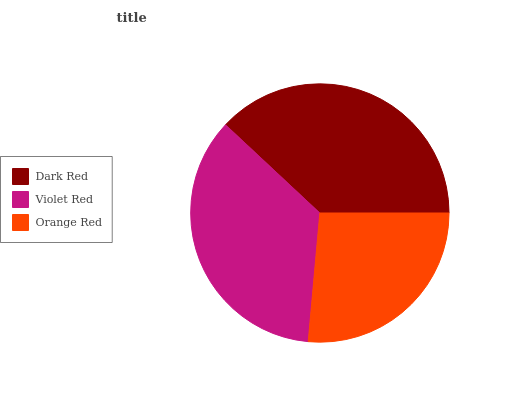Is Orange Red the minimum?
Answer yes or no. Yes. Is Dark Red the maximum?
Answer yes or no. Yes. Is Violet Red the minimum?
Answer yes or no. No. Is Violet Red the maximum?
Answer yes or no. No. Is Dark Red greater than Violet Red?
Answer yes or no. Yes. Is Violet Red less than Dark Red?
Answer yes or no. Yes. Is Violet Red greater than Dark Red?
Answer yes or no. No. Is Dark Red less than Violet Red?
Answer yes or no. No. Is Violet Red the high median?
Answer yes or no. Yes. Is Violet Red the low median?
Answer yes or no. Yes. Is Orange Red the high median?
Answer yes or no. No. Is Orange Red the low median?
Answer yes or no. No. 